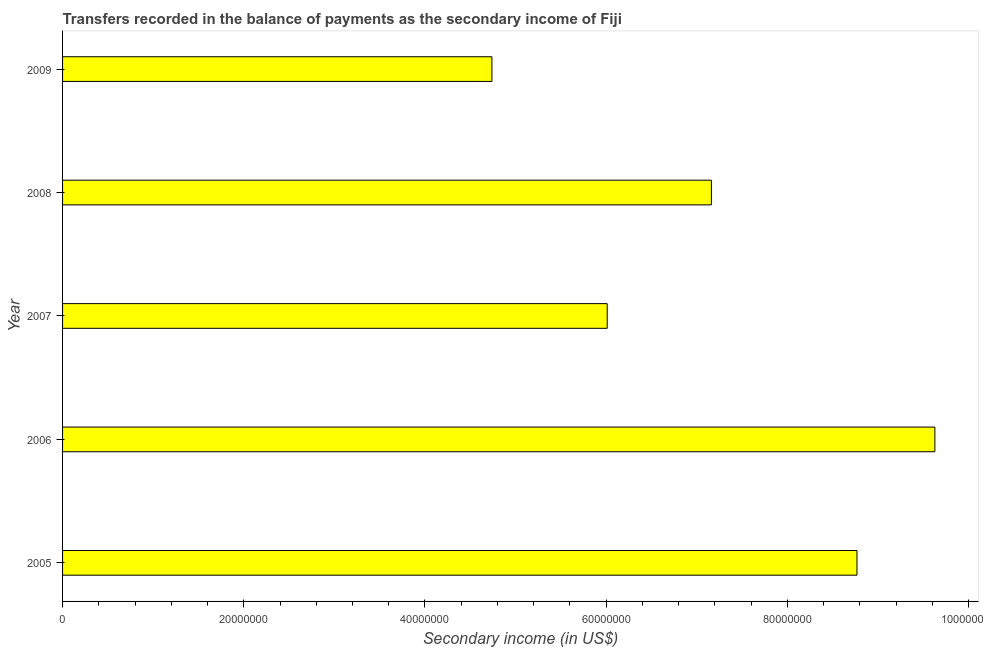What is the title of the graph?
Your answer should be compact. Transfers recorded in the balance of payments as the secondary income of Fiji. What is the label or title of the X-axis?
Offer a terse response. Secondary income (in US$). What is the label or title of the Y-axis?
Provide a succinct answer. Year. What is the amount of secondary income in 2007?
Your answer should be very brief. 6.01e+07. Across all years, what is the maximum amount of secondary income?
Offer a terse response. 9.63e+07. Across all years, what is the minimum amount of secondary income?
Keep it short and to the point. 4.74e+07. In which year was the amount of secondary income maximum?
Your answer should be compact. 2006. What is the sum of the amount of secondary income?
Give a very brief answer. 3.63e+08. What is the difference between the amount of secondary income in 2005 and 2009?
Offer a terse response. 4.03e+07. What is the average amount of secondary income per year?
Make the answer very short. 7.26e+07. What is the median amount of secondary income?
Your answer should be compact. 7.16e+07. In how many years, is the amount of secondary income greater than 72000000 US$?
Your answer should be compact. 2. What is the ratio of the amount of secondary income in 2007 to that in 2009?
Offer a terse response. 1.27. Is the difference between the amount of secondary income in 2007 and 2009 greater than the difference between any two years?
Provide a succinct answer. No. What is the difference between the highest and the second highest amount of secondary income?
Your answer should be compact. 8.60e+06. What is the difference between the highest and the lowest amount of secondary income?
Give a very brief answer. 4.89e+07. Are all the bars in the graph horizontal?
Offer a terse response. Yes. Are the values on the major ticks of X-axis written in scientific E-notation?
Make the answer very short. No. What is the Secondary income (in US$) of 2005?
Your answer should be compact. 8.77e+07. What is the Secondary income (in US$) of 2006?
Give a very brief answer. 9.63e+07. What is the Secondary income (in US$) in 2007?
Provide a succinct answer. 6.01e+07. What is the Secondary income (in US$) of 2008?
Offer a terse response. 7.16e+07. What is the Secondary income (in US$) in 2009?
Provide a short and direct response. 4.74e+07. What is the difference between the Secondary income (in US$) in 2005 and 2006?
Your response must be concise. -8.60e+06. What is the difference between the Secondary income (in US$) in 2005 and 2007?
Ensure brevity in your answer.  2.76e+07. What is the difference between the Secondary income (in US$) in 2005 and 2008?
Your response must be concise. 1.61e+07. What is the difference between the Secondary income (in US$) in 2005 and 2009?
Make the answer very short. 4.03e+07. What is the difference between the Secondary income (in US$) in 2006 and 2007?
Offer a terse response. 3.62e+07. What is the difference between the Secondary income (in US$) in 2006 and 2008?
Your answer should be compact. 2.47e+07. What is the difference between the Secondary income (in US$) in 2006 and 2009?
Offer a very short reply. 4.89e+07. What is the difference between the Secondary income (in US$) in 2007 and 2008?
Your answer should be very brief. -1.15e+07. What is the difference between the Secondary income (in US$) in 2007 and 2009?
Your response must be concise. 1.27e+07. What is the difference between the Secondary income (in US$) in 2008 and 2009?
Make the answer very short. 2.42e+07. What is the ratio of the Secondary income (in US$) in 2005 to that in 2006?
Ensure brevity in your answer.  0.91. What is the ratio of the Secondary income (in US$) in 2005 to that in 2007?
Keep it short and to the point. 1.46. What is the ratio of the Secondary income (in US$) in 2005 to that in 2008?
Make the answer very short. 1.22. What is the ratio of the Secondary income (in US$) in 2005 to that in 2009?
Offer a terse response. 1.85. What is the ratio of the Secondary income (in US$) in 2006 to that in 2007?
Make the answer very short. 1.6. What is the ratio of the Secondary income (in US$) in 2006 to that in 2008?
Your answer should be very brief. 1.34. What is the ratio of the Secondary income (in US$) in 2006 to that in 2009?
Provide a succinct answer. 2.03. What is the ratio of the Secondary income (in US$) in 2007 to that in 2008?
Give a very brief answer. 0.84. What is the ratio of the Secondary income (in US$) in 2007 to that in 2009?
Your answer should be compact. 1.27. What is the ratio of the Secondary income (in US$) in 2008 to that in 2009?
Your answer should be compact. 1.51. 